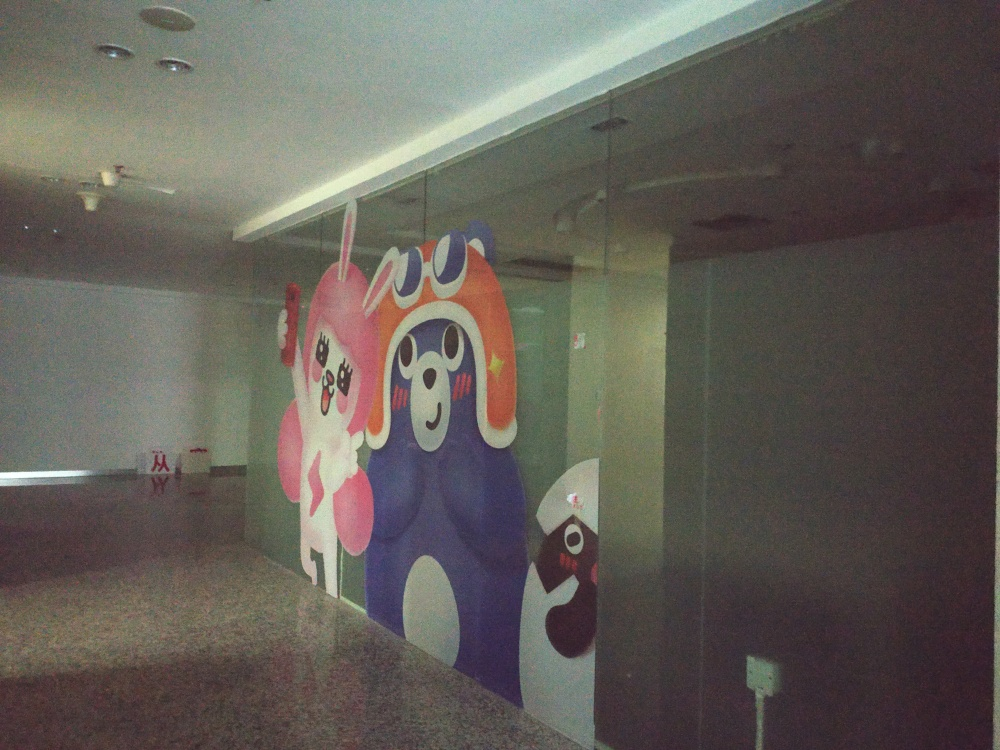Are there any quality issues with this image? Yes, there are several quality issues with this image. The overall lighting is poor, casting dim, uneven light across the scene, which results in a lack of vibrancy in the colors. There is noticeable graininess and lack of sharpness, possibly due to a low-resolution capture or high ISO setting. Additionally, the angle and composition might not showcase the mural effectively, with perspective slightly skewed, which can detract from appreciating the artwork fully. 